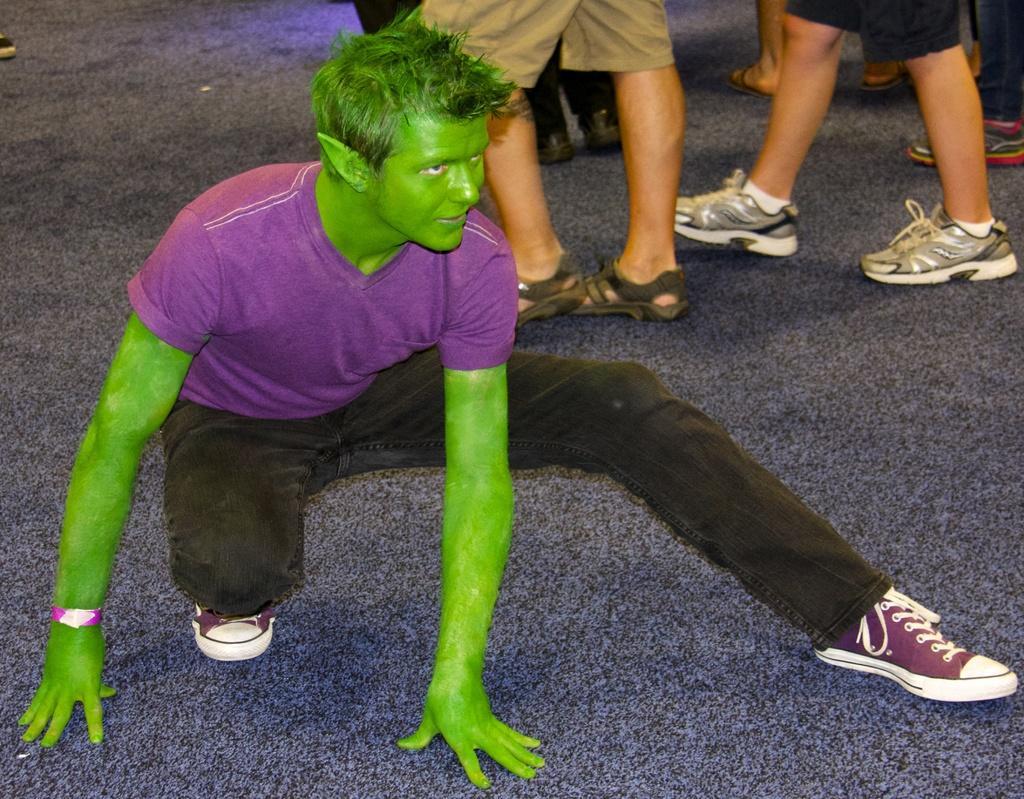Could you give a brief overview of what you see in this image? In this picture I can see few people and looks like few people walking in the back. 